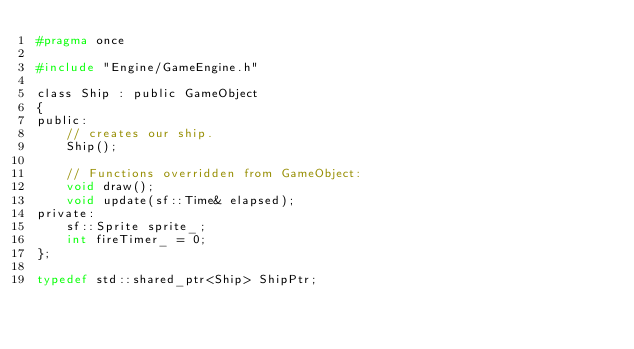Convert code to text. <code><loc_0><loc_0><loc_500><loc_500><_C_>#pragma once

#include "Engine/GameEngine.h"

class Ship : public GameObject
{
public:
	// creates our ship.
	Ship();

	// Functions overridden from GameObject:
	void draw();
	void update(sf::Time& elapsed);
private:
	sf::Sprite sprite_;
	int fireTimer_ = 0;
};

typedef std::shared_ptr<Ship> ShipPtr;
</code> 